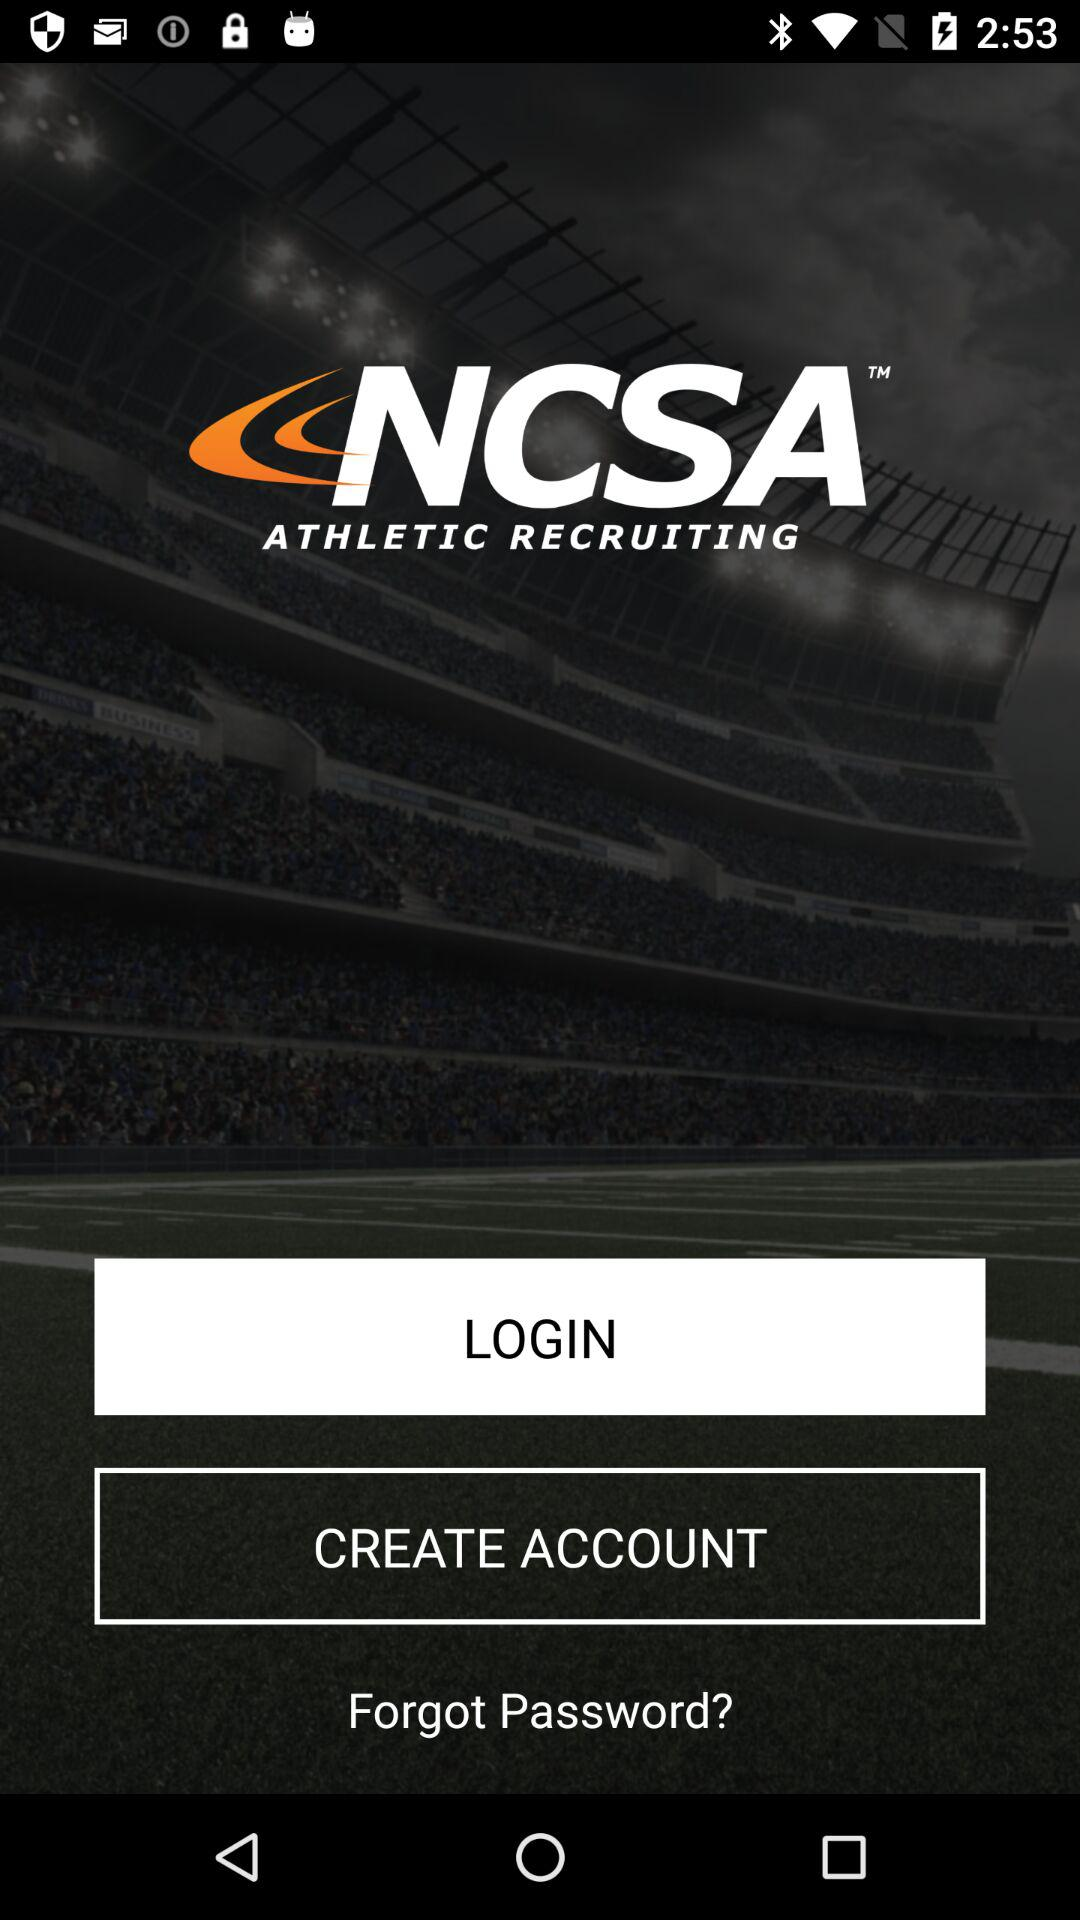What is the application name? The application name is "NCSA". 